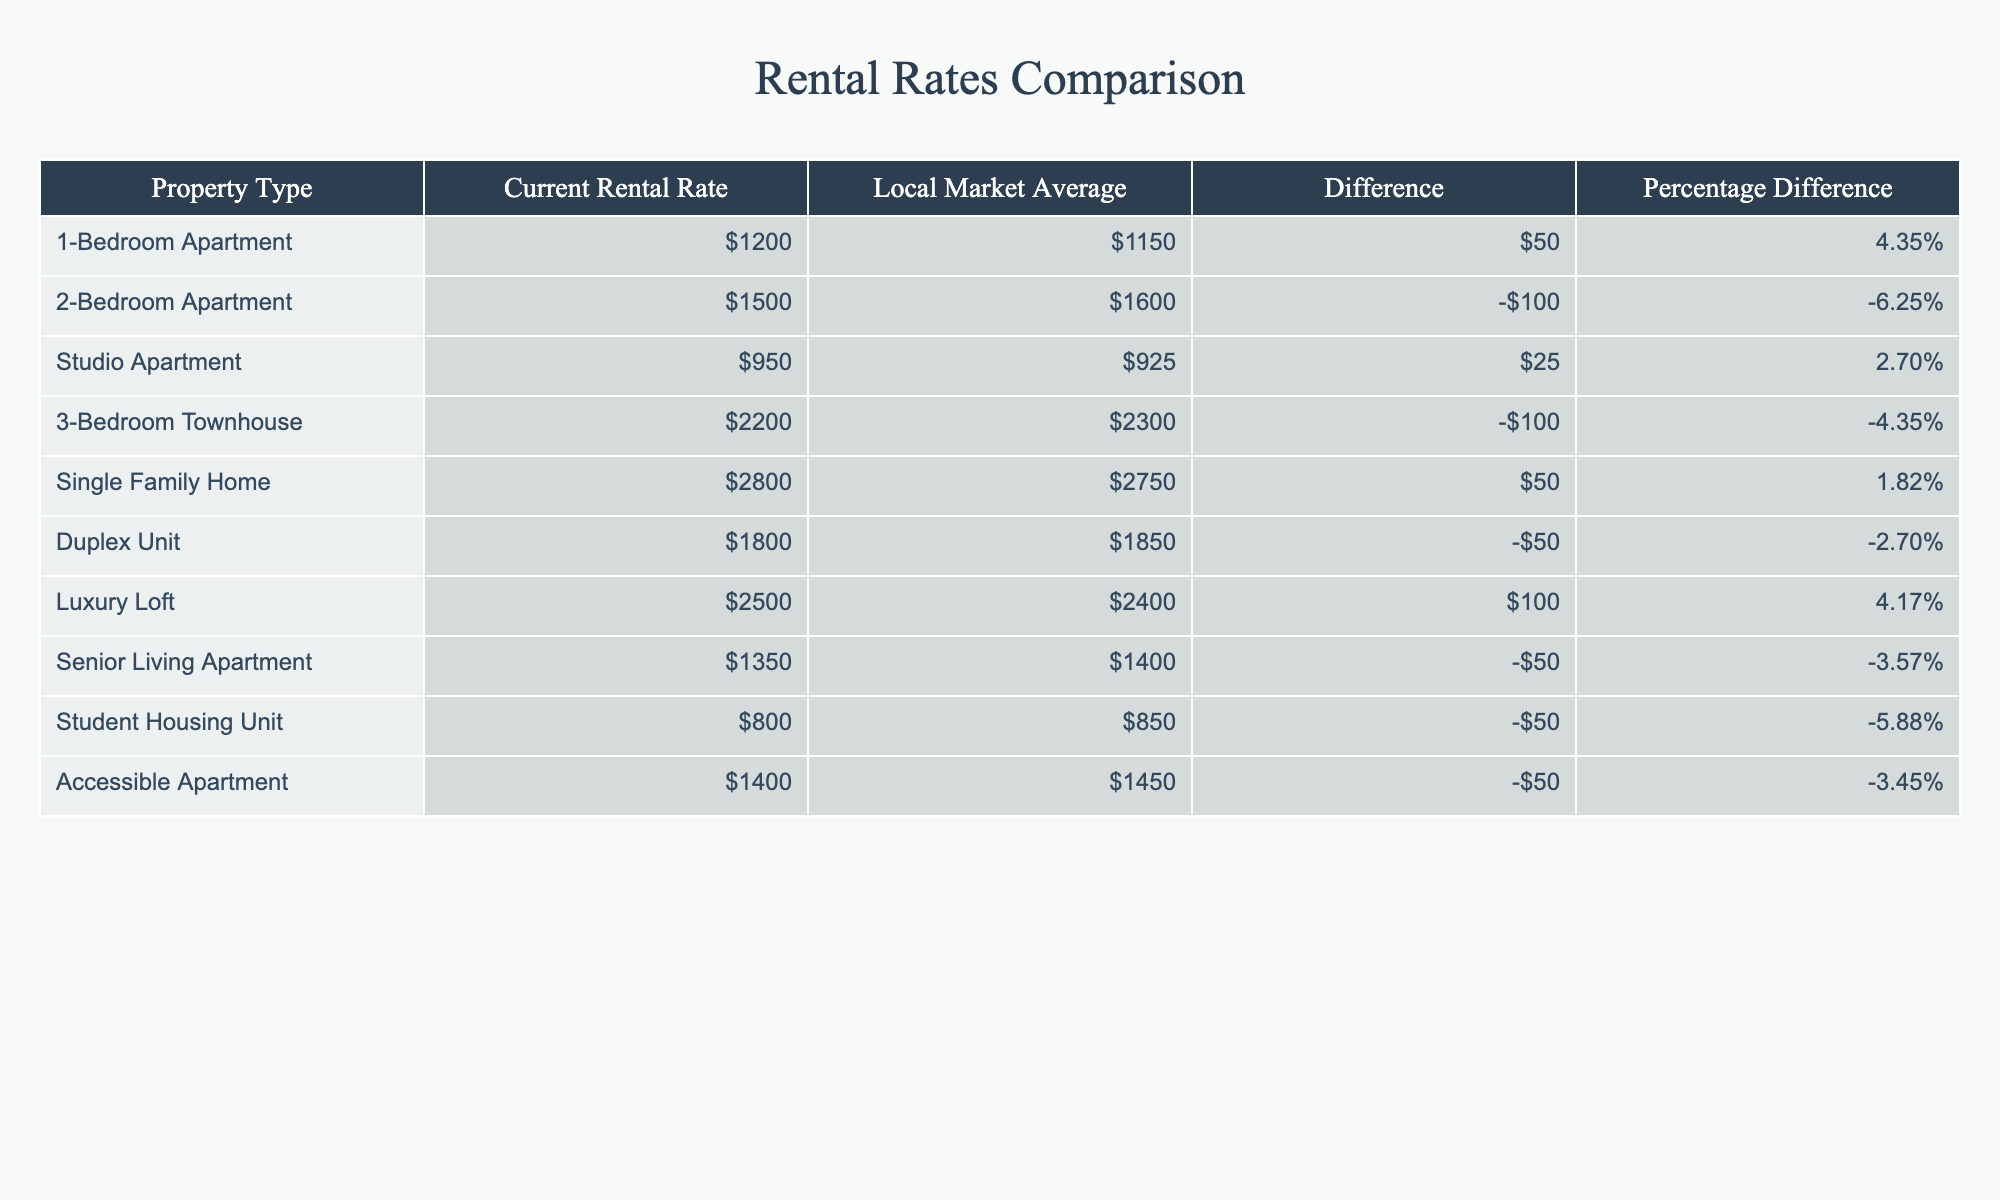What is the current rental rate for a 2-bedroom apartment? The current rental rate for a 2-bedroom apartment is listed in the table. Referring directly to the row for the 2-bedroom apartment, the current rate is $1500.
Answer: $1500 How much does the current rental rate of a 3-bedroom townhouse differ from the local market average? The difference is shown in the table for the 3-bedroom townhouse. The current rental rate is $2200, while the local market average is $2300, resulting in a difference of -$100.
Answer: -$100 Is the current rental rate for a studio apartment higher than the local market average? By comparing the values for the studio apartment in the table, the current rate of $950 is higher than the local market average of $925, making the statement true.
Answer: No What is the percentage difference between the current rental rate and local market average for the duplex unit? The table states the difference for the duplex unit is -$50 and the percentage difference is -2.70%. This percentage indicates that the current rate is lower than the market average by this percentage.
Answer: -2.70% Which property type has the highest current rental rate? The table lists various property types along with their current rental rates. The single family home has the highest rate at $2800, compared to others listed.
Answer: Single Family Home What is the average current rental rate of all the properties listed in the table? To find the average, sum all the current rental rates: $1200 + $1500 + $950 + $2200 + $2800 + $1800 + $2500 + $1350 + $800 + $1400 = $15,500. There are 10 properties, so the average is $15,500 / 10 = $1550.
Answer: $1550 Which property types have a current rental rate lower than the local market average? By reviewing the table, the 2-bedroom apartment, 3-bedroom townhouse, duplex unit, senior living apartment, student housing unit, and accessible apartment have current rates lower than their respective average rates.
Answer: 6 Property Types What is the combined difference of current rental rates from the local market average for all property types? Summing up the differences in the table: $50 - $100 + $25 - $100 + $50 - $50 + $100 - $50 - $50 - $50 = -$100. Thus, the total combined difference is -$100, indicating overall that current rates are lower than local averages.
Answer: -$100 How many property types have a positive percentage difference? The table shows that the property types with a positive percentage difference are the 1-bedroom apartment, studio apartment, luxury loft, and single family home, totaling four types.
Answer: 4 Types Is any property type's current rental rate exactly the same as the local market average? Scanning through the table, none of the current rental rates match exactly with their respective local market averages; hence, the answer is no.
Answer: No 